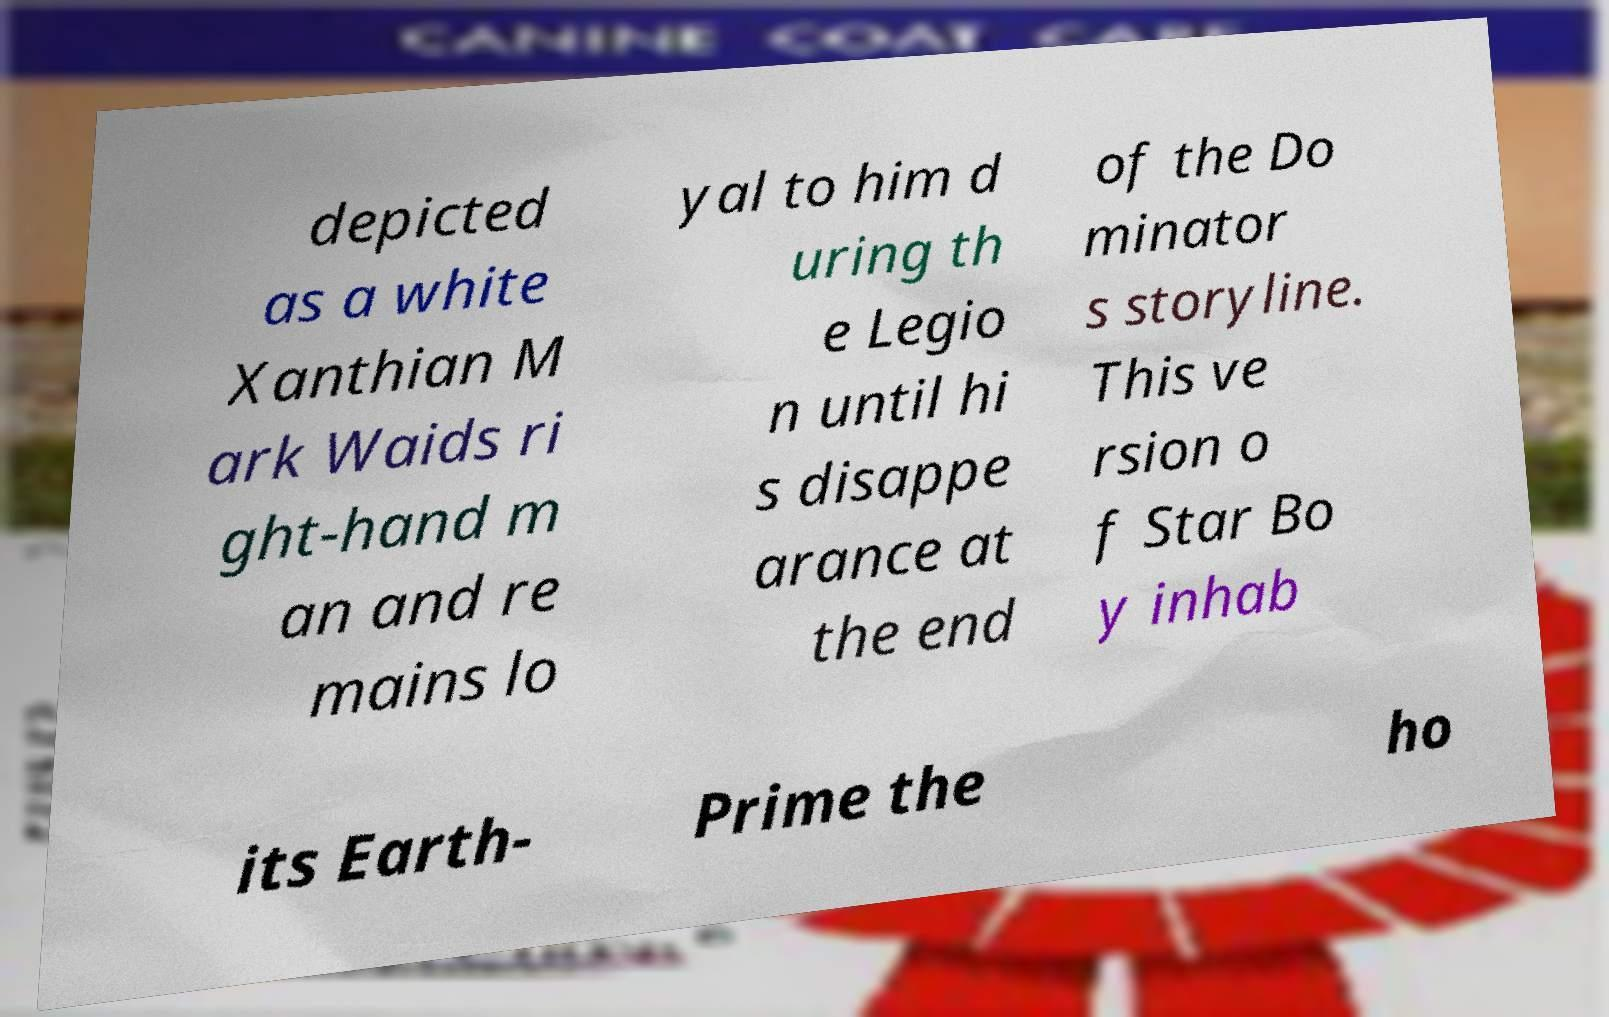Could you extract and type out the text from this image? depicted as a white Xanthian M ark Waids ri ght-hand m an and re mains lo yal to him d uring th e Legio n until hi s disappe arance at the end of the Do minator s storyline. This ve rsion o f Star Bo y inhab its Earth- Prime the ho 